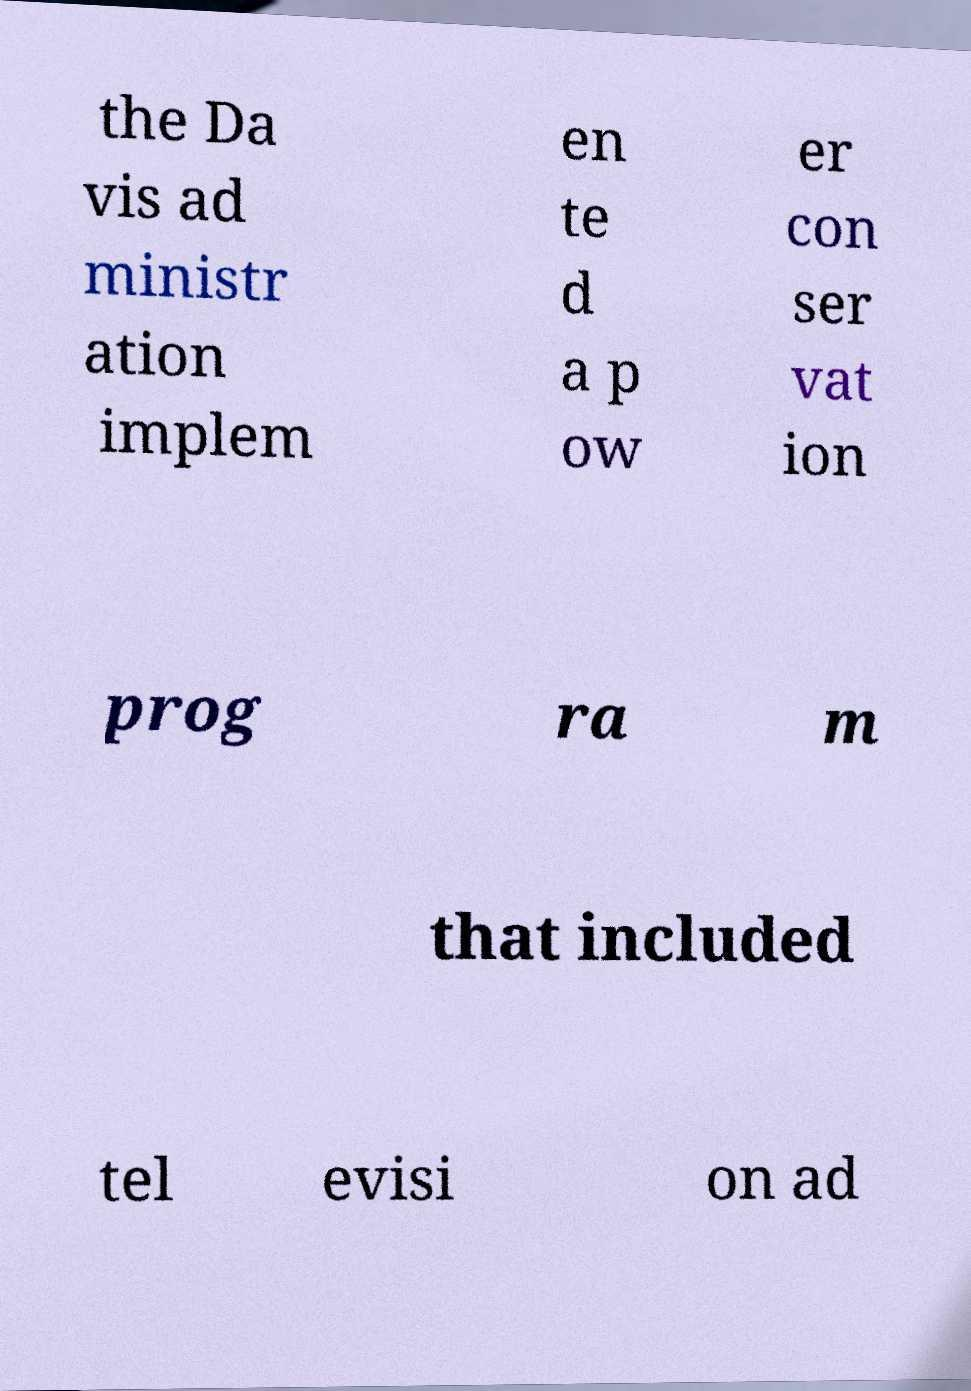Can you read and provide the text displayed in the image?This photo seems to have some interesting text. Can you extract and type it out for me? the Da vis ad ministr ation implem en te d a p ow er con ser vat ion prog ra m that included tel evisi on ad 